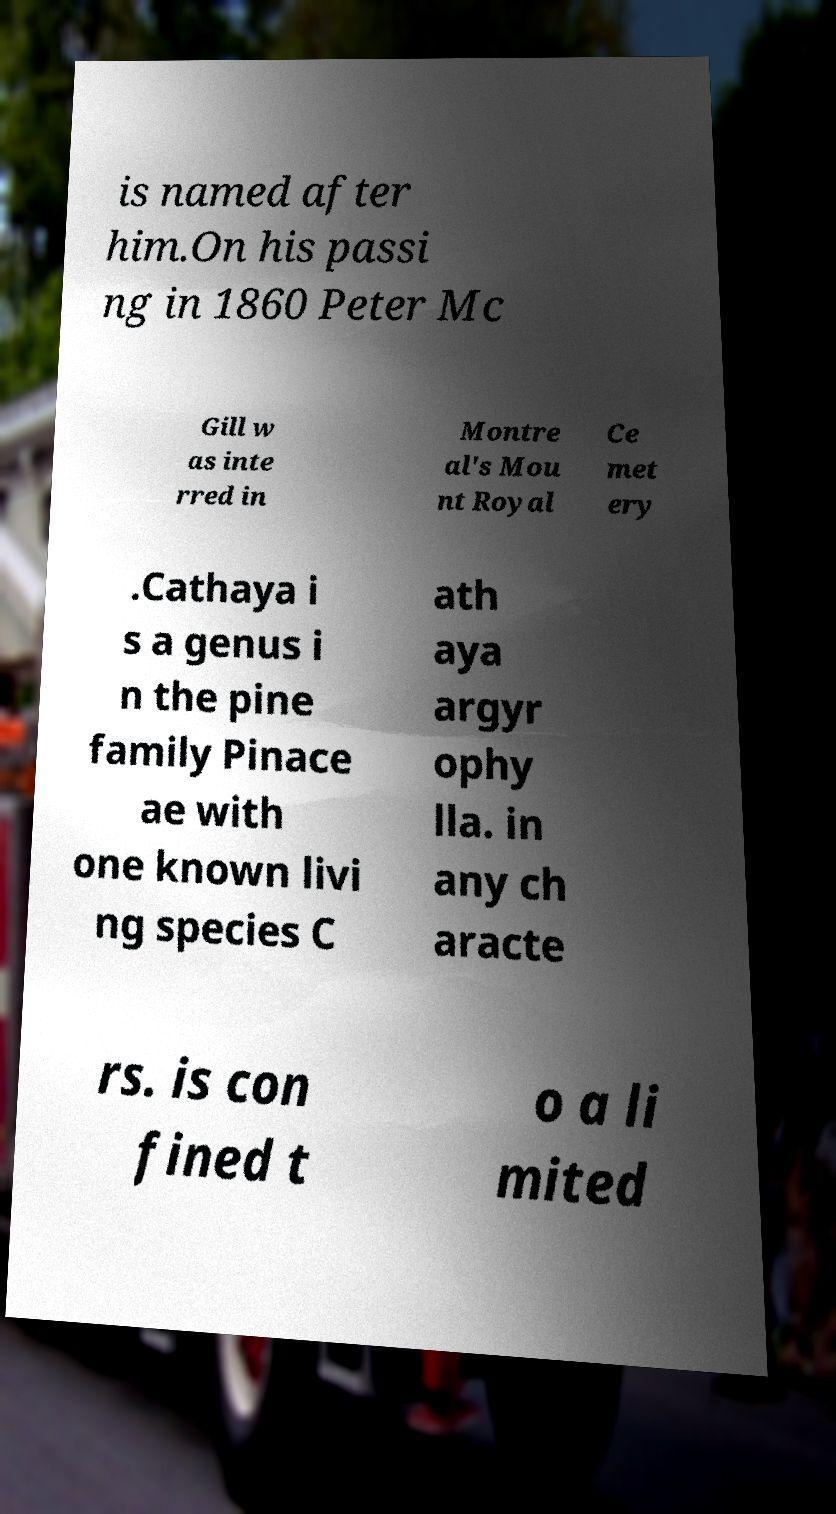For documentation purposes, I need the text within this image transcribed. Could you provide that? is named after him.On his passi ng in 1860 Peter Mc Gill w as inte rred in Montre al's Mou nt Royal Ce met ery .Cathaya i s a genus i n the pine family Pinace ae with one known livi ng species C ath aya argyr ophy lla. in any ch aracte rs. is con fined t o a li mited 